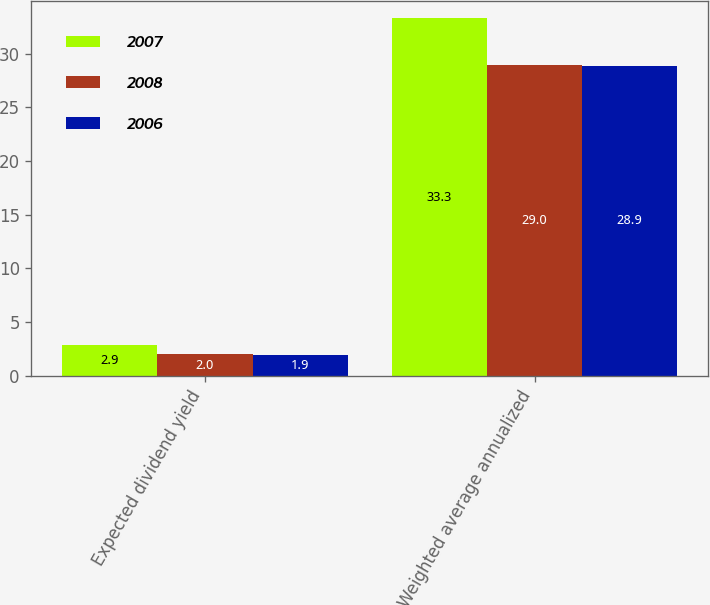<chart> <loc_0><loc_0><loc_500><loc_500><stacked_bar_chart><ecel><fcel>Expected dividend yield<fcel>Weighted average annualized<nl><fcel>2007<fcel>2.9<fcel>33.3<nl><fcel>2008<fcel>2<fcel>29<nl><fcel>2006<fcel>1.9<fcel>28.9<nl></chart> 